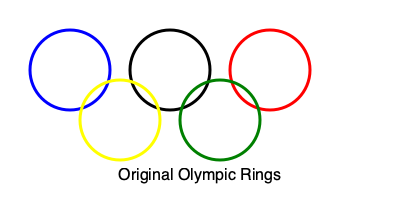Which of the following rotations correctly represents the official Olympic rings logo as it appeared in the 1924 Paris Olympics, the first time it was used on the Olympic flag?
A) 90 degrees clockwise
B) 180 degrees
C) 90 degrees counterclockwise
D) No rotation (as shown) To answer this question, we need to consider the historical context and the evolution of the Olympic rings logo:

1. The Olympic rings were designed by Baron Pierre de Coubertin in 1912.

2. The logo was officially adopted by the International Olympic Committee (IOC) in 1914.

3. The 1924 Paris Olympics was the first time the Olympic rings appeared on the official Olympic flag.

4. The original design, as conceived by Coubertin and used in 1924, had the rings interlaced in a specific order: blue, yellow, black, green, and red.

5. In the image provided, the rings are arranged as they appear in the modern Olympic logo: blue, yellow, black, green, and red, from left to right and top to bottom.

6. This arrangement is the same as the original 1924 design, with no rotation applied.

Therefore, the correct answer is that no rotation is needed; the logo is already in its original 1924 orientation.
Answer: D) No rotation (as shown) 